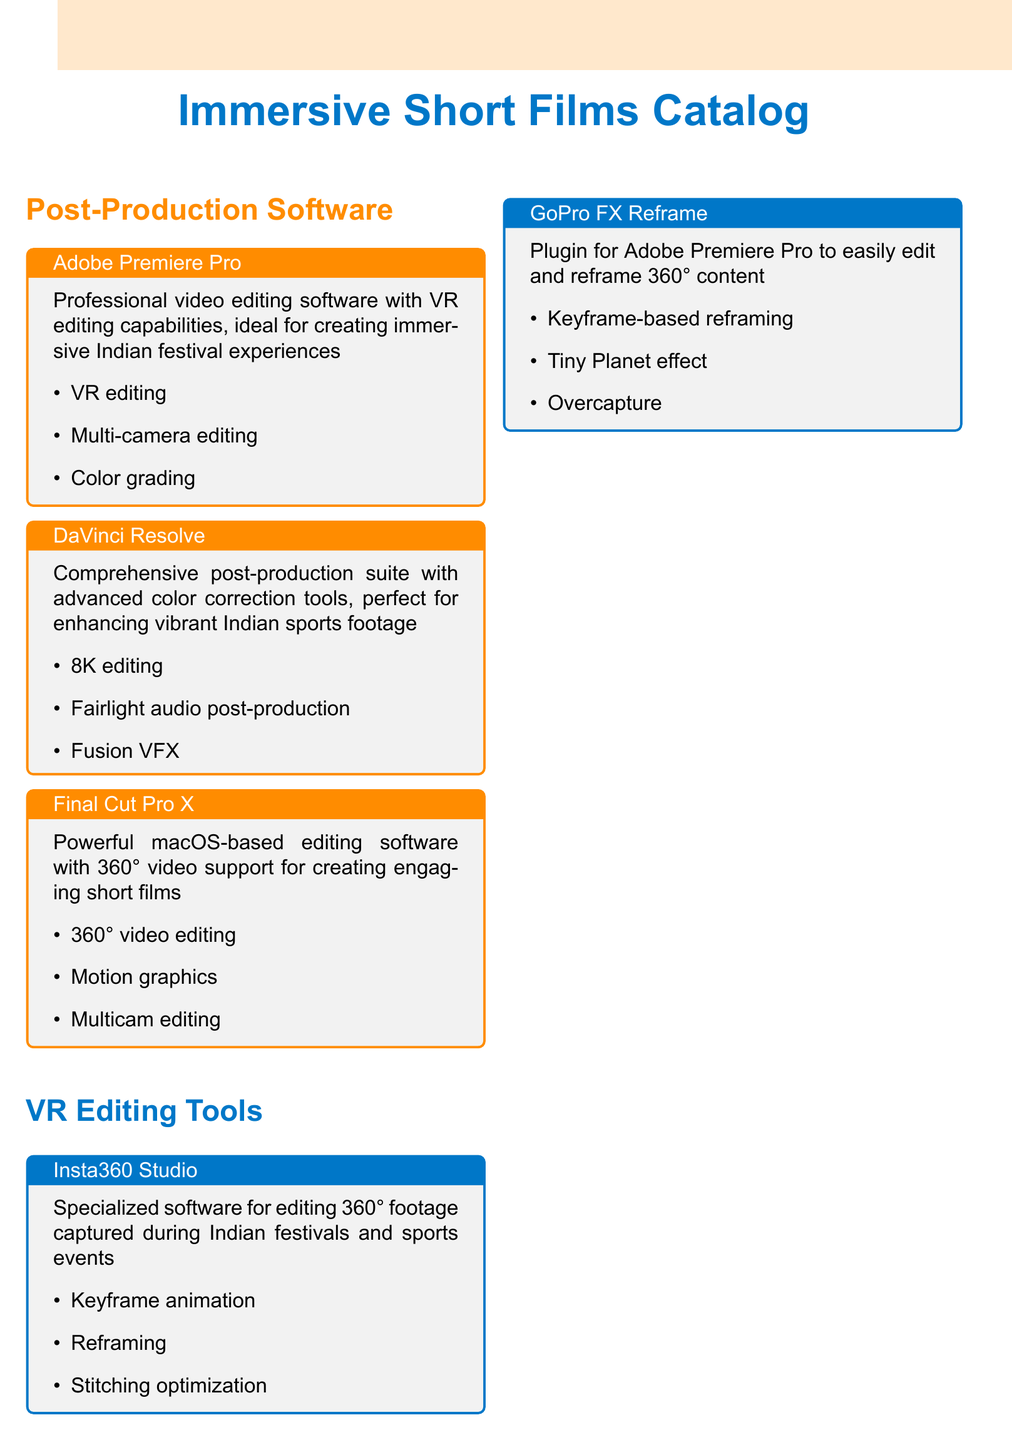What is the title of the catalog? The title is presented prominently at the top of the document as "Immersive Short Films Catalog."
Answer: Immersive Short Films Catalog Which software is mentioned for advanced color correction? The document lists DaVinci Resolve as the software with advanced color correction tools.
Answer: DaVinci Resolve What is a feature of Adobe Premiere Pro? The document highlights VR editing as a key feature of Adobe Premiere Pro.
Answer: VR editing Which surround sound system is associated with spatial audio microphones? Sennheiser AMBEO is the surround sound system linked with spatial audio microphones.
Answer: Sennheiser AMBEO What type of video editing does Final Cut Pro X support? Final Cut Pro X supports 360° video editing, as specified in the document.
Answer: 360° video editing How many tools are listed under VR Editing Tools? There are two tools listed under VR Editing Tools: Insta360 Studio and GoPro FX Reframe.
Answer: 2 Which hardware is known for high-performance capture and playback? Blackmagic Design DeckLink 8K Pro is noted for high-performance capture and playback.
Answer: Blackmagic Design DeckLink 8K Pro What audio post-production feature does DaVinci Resolve include? The document states that DaVinci Resolve includes Fairlight audio post-production.
Answer: Fairlight audio post-production Is the NVIDIA GeForce RTX 3090 a GPU or a CPU? The document describes the NVIDIA GeForce RTX 3090 as a powerful GPU.
Answer: GPU 